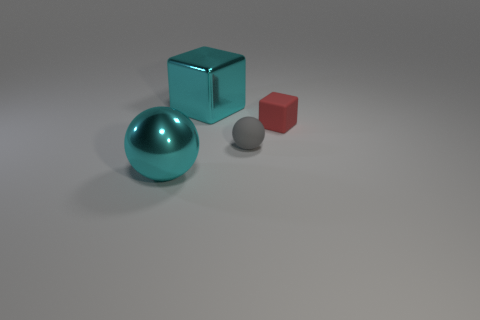Add 4 large things. How many objects exist? 8 Add 3 large metal blocks. How many large metal blocks are left? 4 Add 4 small cubes. How many small cubes exist? 5 Subtract 0 red balls. How many objects are left? 4 Subtract all tiny brown metallic cylinders. Subtract all red blocks. How many objects are left? 3 